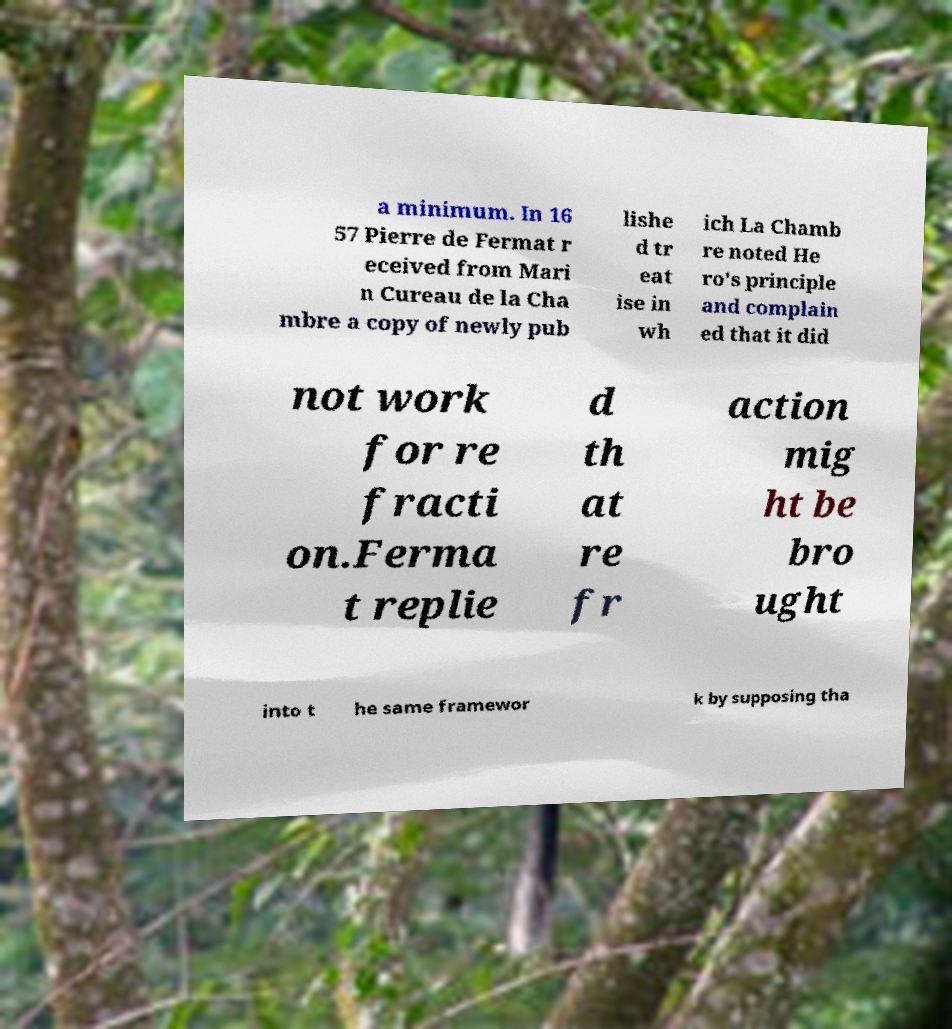Can you accurately transcribe the text from the provided image for me? a minimum. In 16 57 Pierre de Fermat r eceived from Mari n Cureau de la Cha mbre a copy of newly pub lishe d tr eat ise in wh ich La Chamb re noted He ro's principle and complain ed that it did not work for re fracti on.Ferma t replie d th at re fr action mig ht be bro ught into t he same framewor k by supposing tha 